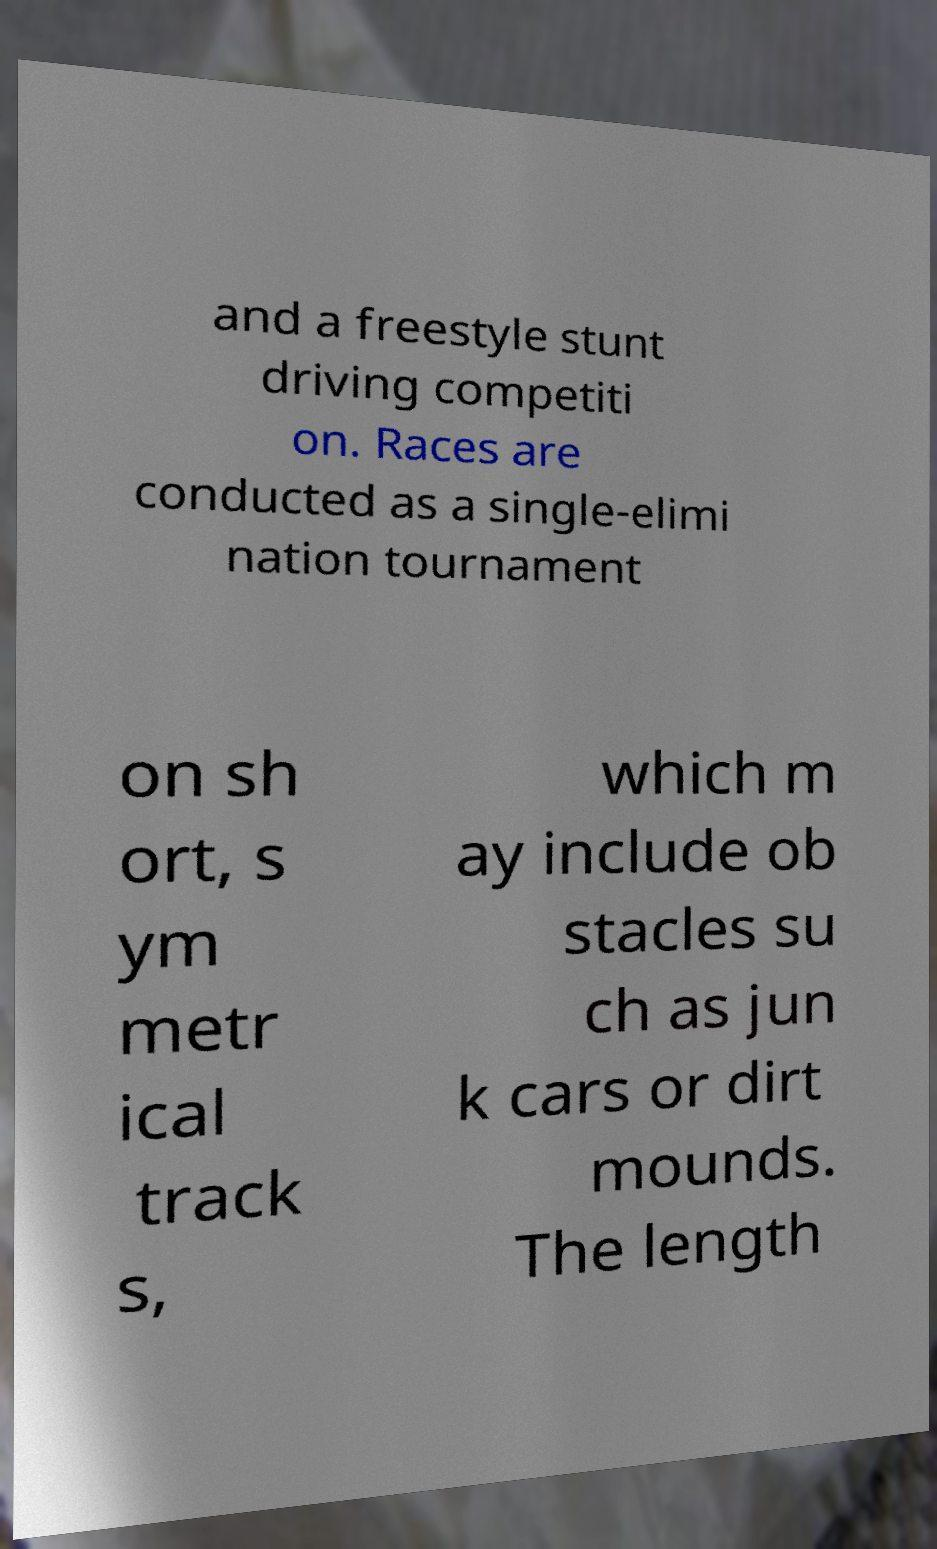What messages or text are displayed in this image? I need them in a readable, typed format. and a freestyle stunt driving competiti on. Races are conducted as a single-elimi nation tournament on sh ort, s ym metr ical track s, which m ay include ob stacles su ch as jun k cars or dirt mounds. The length 